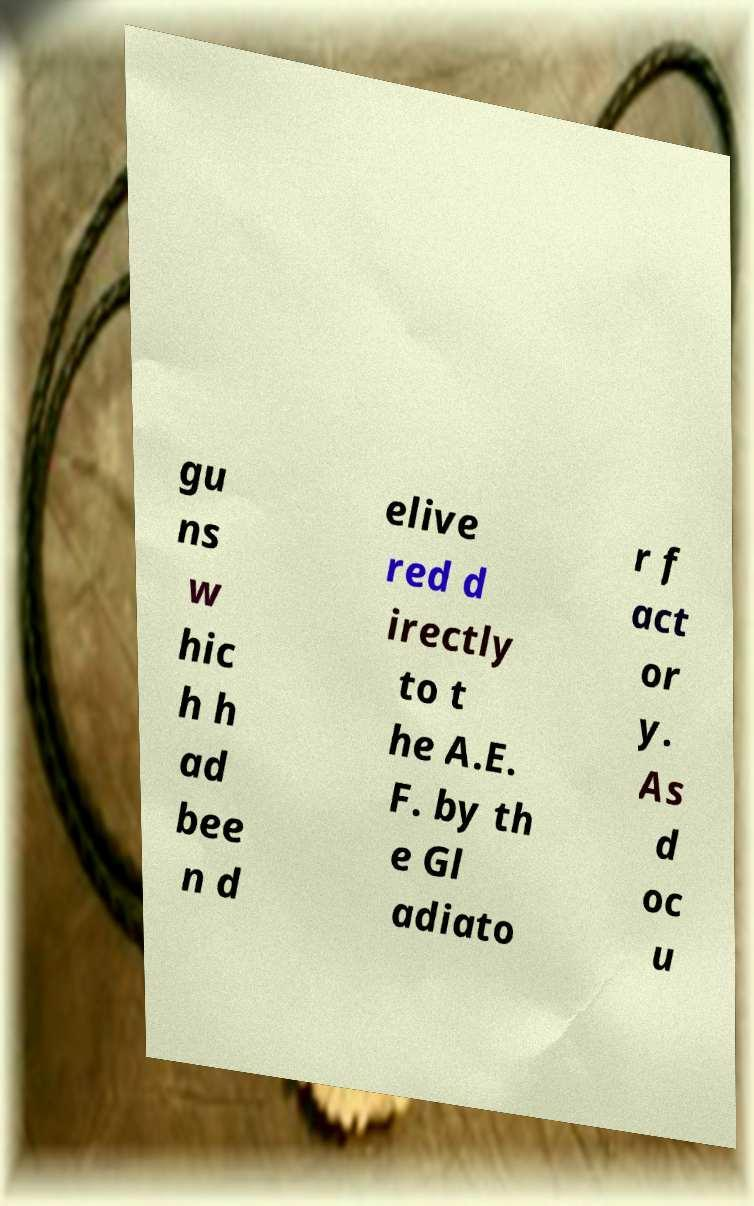Can you accurately transcribe the text from the provided image for me? gu ns w hic h h ad bee n d elive red d irectly to t he A.E. F. by th e Gl adiato r f act or y. As d oc u 